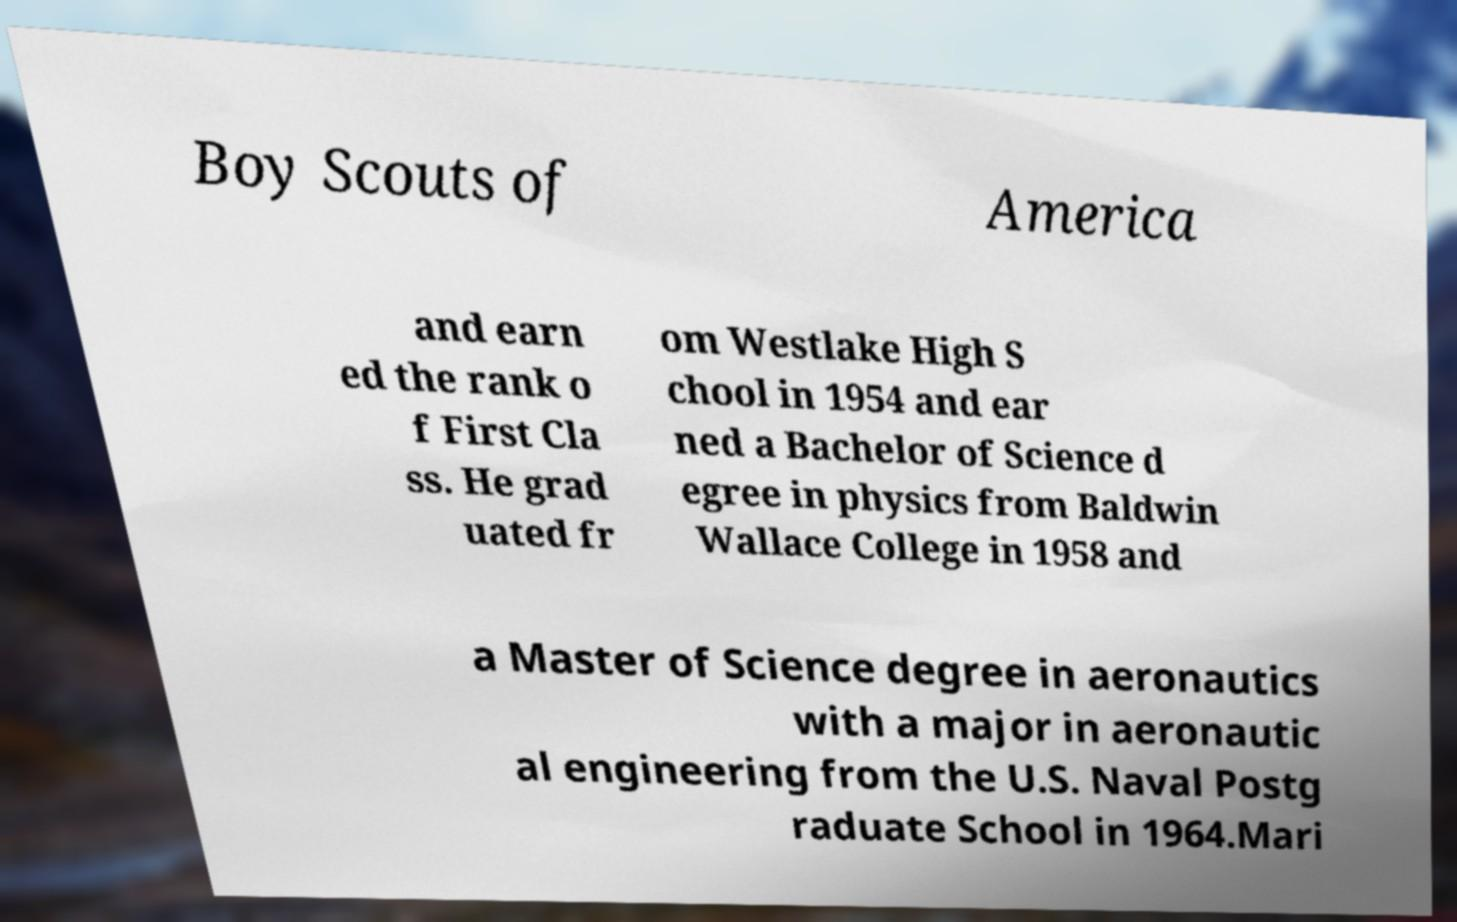There's text embedded in this image that I need extracted. Can you transcribe it verbatim? Boy Scouts of America and earn ed the rank o f First Cla ss. He grad uated fr om Westlake High S chool in 1954 and ear ned a Bachelor of Science d egree in physics from Baldwin Wallace College in 1958 and a Master of Science degree in aeronautics with a major in aeronautic al engineering from the U.S. Naval Postg raduate School in 1964.Mari 